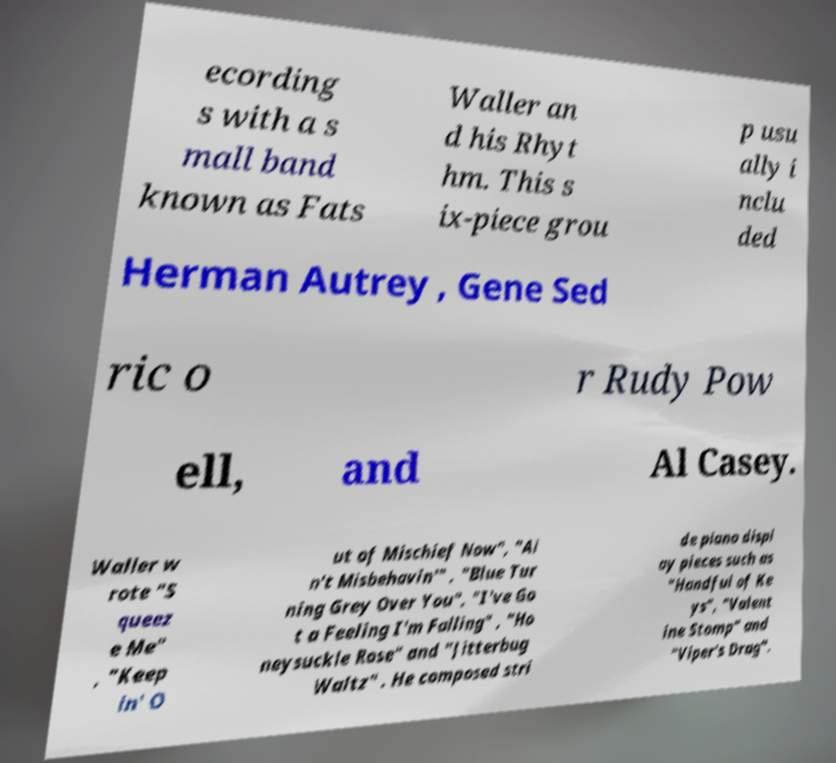What messages or text are displayed in this image? I need them in a readable, typed format. ecording s with a s mall band known as Fats Waller an d his Rhyt hm. This s ix-piece grou p usu ally i nclu ded Herman Autrey , Gene Sed ric o r Rudy Pow ell, and Al Casey. Waller w rote "S queez e Me" , "Keep in' O ut of Mischief Now", "Ai n't Misbehavin'" , "Blue Tur ning Grey Over You", "I've Go t a Feeling I'm Falling" , "Ho neysuckle Rose" and "Jitterbug Waltz" . He composed stri de piano displ ay pieces such as "Handful of Ke ys", "Valent ine Stomp" and "Viper's Drag". 